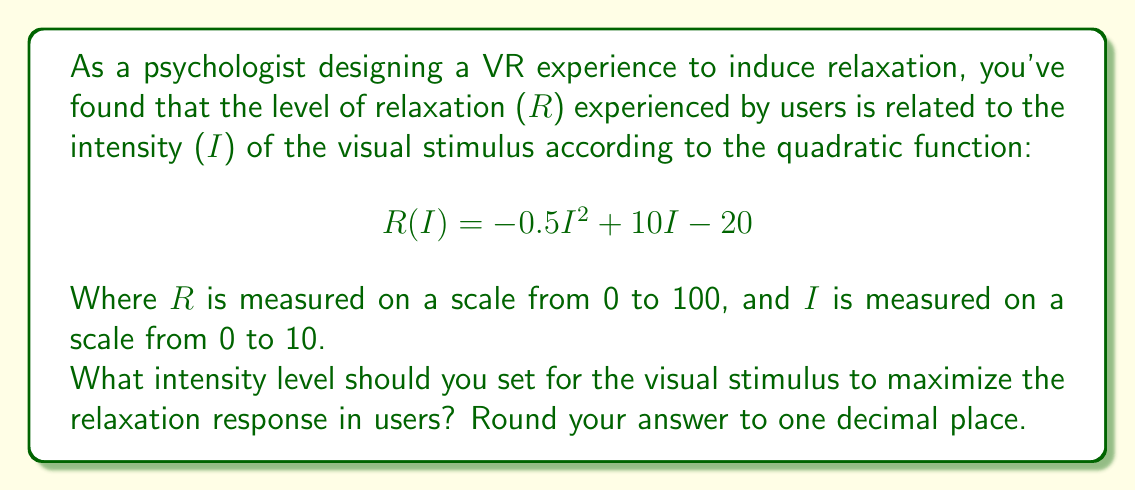Teach me how to tackle this problem. To find the optimal intensity level that maximizes the relaxation response, we need to find the vertex of the quadratic function. The vertex represents the maximum point of the parabola.

For a quadratic function in the form $f(x) = ax^2 + bx + c$, the x-coordinate of the vertex is given by $x = -\frac{b}{2a}$.

In our case:
$a = -0.5$
$b = 10$
$c = -20$

Substituting these values into the formula:

$$ I = -\frac{10}{2(-0.5)} = -\frac{10}{-1} = 10 $$

To verify this is a maximum (not a minimum), we can check that $a$ is negative, which it is ($a = -0.5$).

We can also calculate the maximum relaxation level by substituting $I = 10$ into the original function:

$$ R(10) = -0.5(10)^2 + 10(10) - 20 $$
$$ = -0.5(100) + 100 - 20 $$
$$ = -50 + 100 - 20 $$
$$ = 30 $$

This confirms that the relaxation level reaches its maximum at $I = 10$.

Since the question asks to round to one decimal place, and 10 is already a whole number, no rounding is necessary.
Answer: 10.0 